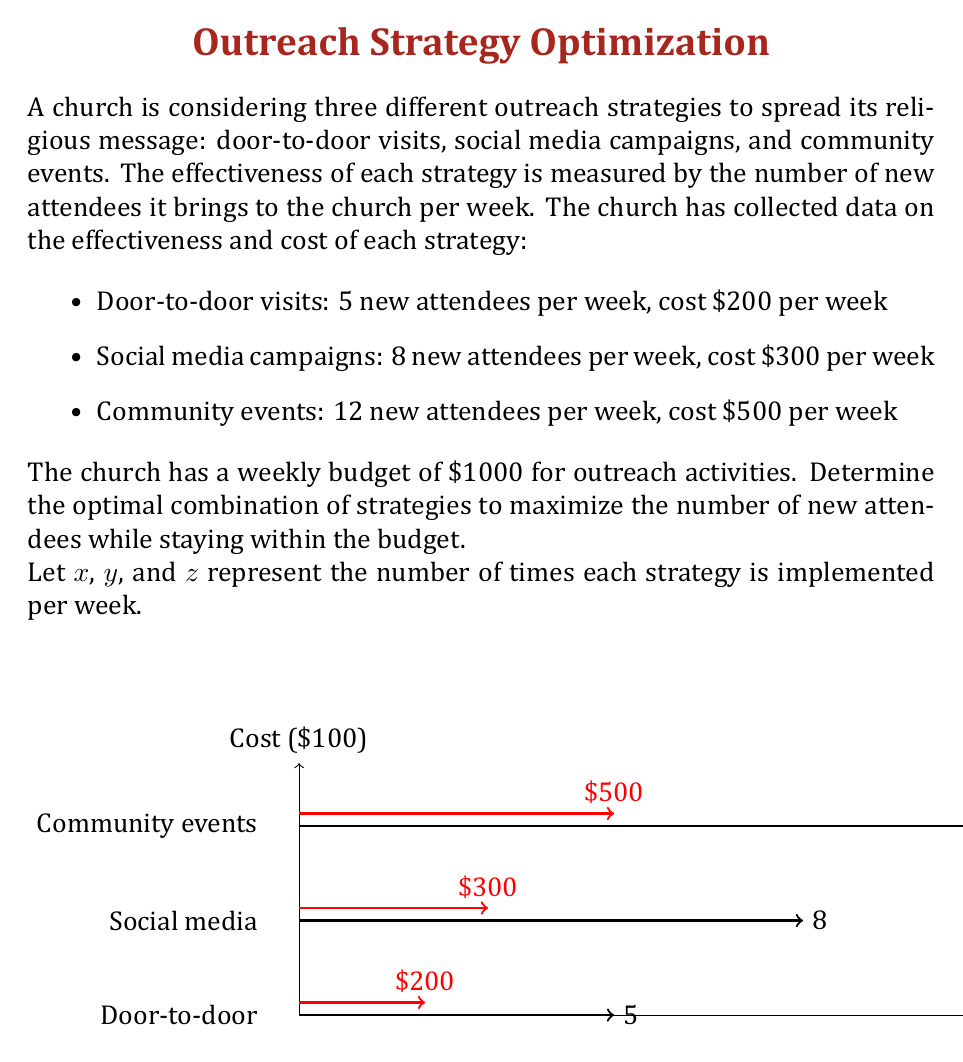Show me your answer to this math problem. To solve this problem, we'll use linear programming. Let's formulate the problem:

Objective function: Maximize $5x + 8y + 12z$

Subject to the constraints:
1. Budget constraint: $200x + 300y + 500z \leq 1000$
2. Non-negativity constraints: $x \geq 0$, $y \geq 0$, $z \geq 0$

We can solve this using the simplex method or graphically. Let's use the graphical method for visualization:

1. Plot the budget constraint: $200x + 300y + 500z = 1000$
2. Consider the non-negativity constraints
3. Find the vertices of the feasible region
4. Evaluate the objective function at each vertex

The vertices are:
- (5, 0, 0): 25 new attendees
- (0, 3.33, 0): 26.64 new attendees
- (0, 0, 2): 24 new attendees
- (2.5, 1.67, 0): 26.36 new attendees
- (1, 0, 1.6): 24.2 new attendees
- (0, 1.67, 1.33): 29.36 new attendees

The optimal solution is at the vertex (0, 1.67, 1.33), which means:
- No door-to-door visits
- 1.67 social media campaigns per week
- 1.33 community events per week

This results in approximately 29.36 new attendees per week.

However, since we can't implement fractional strategies, we need to round down to the nearest integer:
- 1 social media campaign
- 1 community event

This gives us: $8 + 12 = 20$ new attendees per week, with a total cost of $300 + $500 = $800$, which is within the budget.
Answer: 1 social media campaign and 1 community event per week, bringing 20 new attendees. 